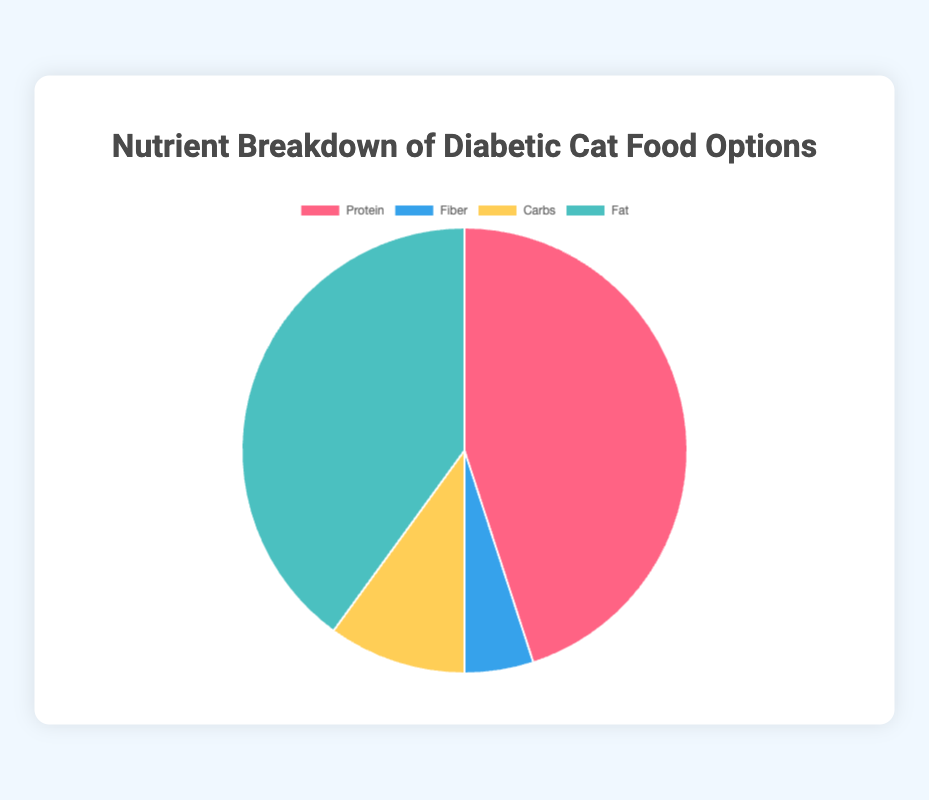Which diet has the highest percentage of Protein? To determine which diet has the highest percentage of Protein, we look at the 'Protein' values for each diet. The 'High-Protein Diet for Diabetic Cats' has 45%, which is the highest compared to the other diets.
Answer: High-Protein Diet for Diabetic Cats How much higher is the Fiber content in the Fiber-Rich Diabetic Cat Food compared to the High-Protein Diet for Diabetic Cats? To determine the difference in Fiber content between these two diets, subtract the percentage of Fiber in the High-Protein Diet (5%) from the Fiber-Rich Diabetic Cat Food (20%). The calculation is 20% - 5% = 15%.
Answer: 15% What is the average percentage of Carbs across all four diets? To find the average Carbs percentage, add the Carbs percentages from all diets (10% + 8% + 12% + 15%) and then divide by the number of diets (4). The calculation is (10+8+12+15)/4 = 45/4 = 11.25%.
Answer: 11.25% Which diets have a higher percentage of Fat than Protein? Comparing the percentages, the 'High-Protein Diet for Diabetic Cats' has more Protein than Fat. The 'Low-Carb Cat Food for Diabetes' has more Fat (42%) than Protein (40%). The 'Balanced Diet Cat Food for Diabetes' has more Fat (38%) than Protein (35%). The 'Fiber-Rich Diabetic Cat Food' also has more Fat (35%) than Protein (30%).
Answer: Low-Carb Cat Food for Diabetes, Balanced Diet Cat Food for Diabetes, Fiber-Rich Diabetic Cat Food Arrange the diets in descending order by their percentage of Fiber. To sort the diets by Fiber content, arrange them from highest to lowest: Fiber-Rich Diabetic Cat Food (20%), Balanced Diet Cat Food for Diabetes (15%), Low-Carb Cat Food for Diabetes (10%), and High-Protein Diet for Diabetic Cats (5%).
Answer: Fiber-Rich Diabetic Cat Food, Balanced Diet Cat Food for Diabetes, Low-Carb Cat Food for Diabetes, High-Protein Diet for Diabetic Cats Which diet has the most balanced distribution of nutrient sources? To determine the most balanced distribution, we compare the nutrient percentages for each diet. The 'Balanced Diet Cat Food for Diabetes' has similar percentages for Protein (35%), Fiber (15%), Carbs (12%), and Fat (38%), indicating a more balanced distribution than the other diets.
Answer: Balanced Diet Cat Food for Diabetes Is there any diet where Fiber content exceeds Carbs content by more than 10%? We compare the difference between Fiber and Carbs for each diet to see if it exceeds 10%. The Fiber-Rich Diabetic Cat Food has a Fiber content of 20% and Carbs content of 15%, with a difference of 5%, which doesn't exceed 10%. So none of the diets meet this criterion.
Answer: No 